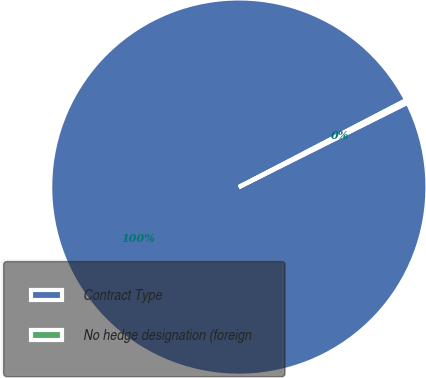Convert chart to OTSL. <chart><loc_0><loc_0><loc_500><loc_500><pie_chart><fcel>Contract Type<fcel>No hedge designation (foreign<nl><fcel>99.75%<fcel>0.25%<nl></chart> 